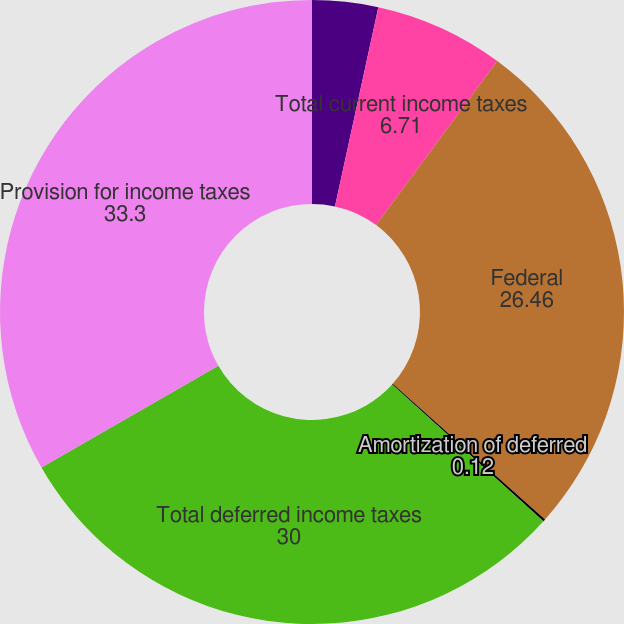<chart> <loc_0><loc_0><loc_500><loc_500><pie_chart><fcel>State<fcel>Total current income taxes<fcel>Federal<fcel>Amortization of deferred<fcel>Total deferred income taxes<fcel>Provision for income taxes<nl><fcel>3.41%<fcel>6.71%<fcel>26.46%<fcel>0.12%<fcel>30.0%<fcel>33.3%<nl></chart> 